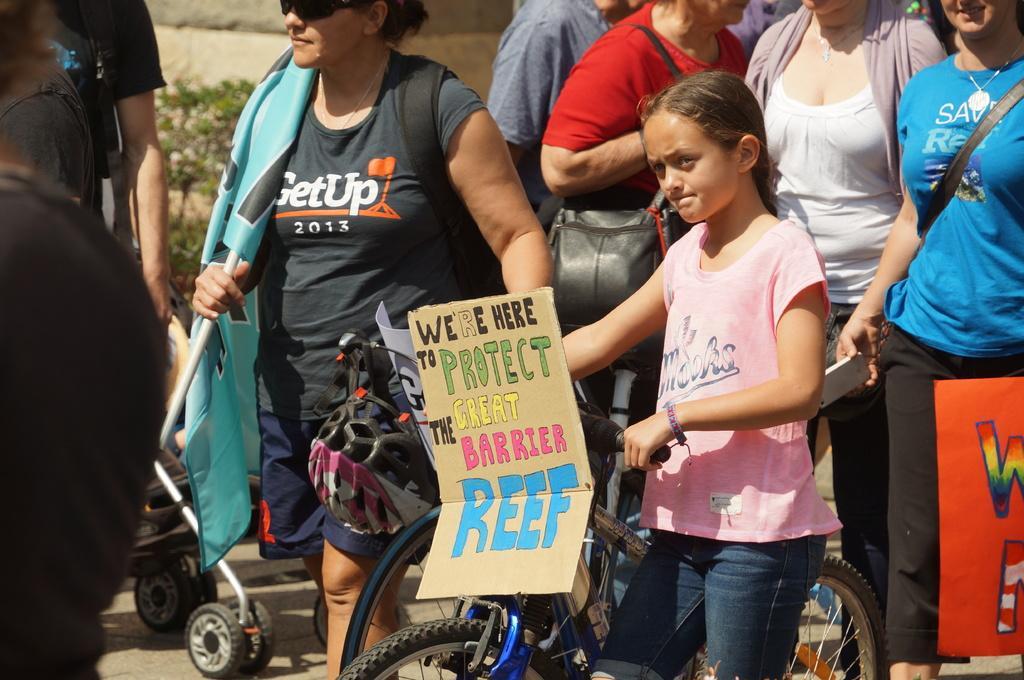Can you describe this image briefly? In the foreground of the picture there are people, bicycle, cart, few are holding placards and flag. In the background we can see a plant and wall. 